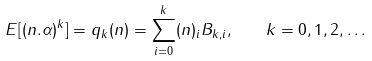Convert formula to latex. <formula><loc_0><loc_0><loc_500><loc_500>E [ ( n . \alpha ) ^ { k } ] = q _ { k } ( n ) = \sum _ { i = 0 } ^ { k } ( n ) _ { i } B _ { k , i } , \quad k = 0 , 1 , 2 , \dots</formula> 